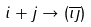Convert formula to latex. <formula><loc_0><loc_0><loc_500><loc_500>i + j \rightarrow ( \overline { \imath \jmath } )</formula> 